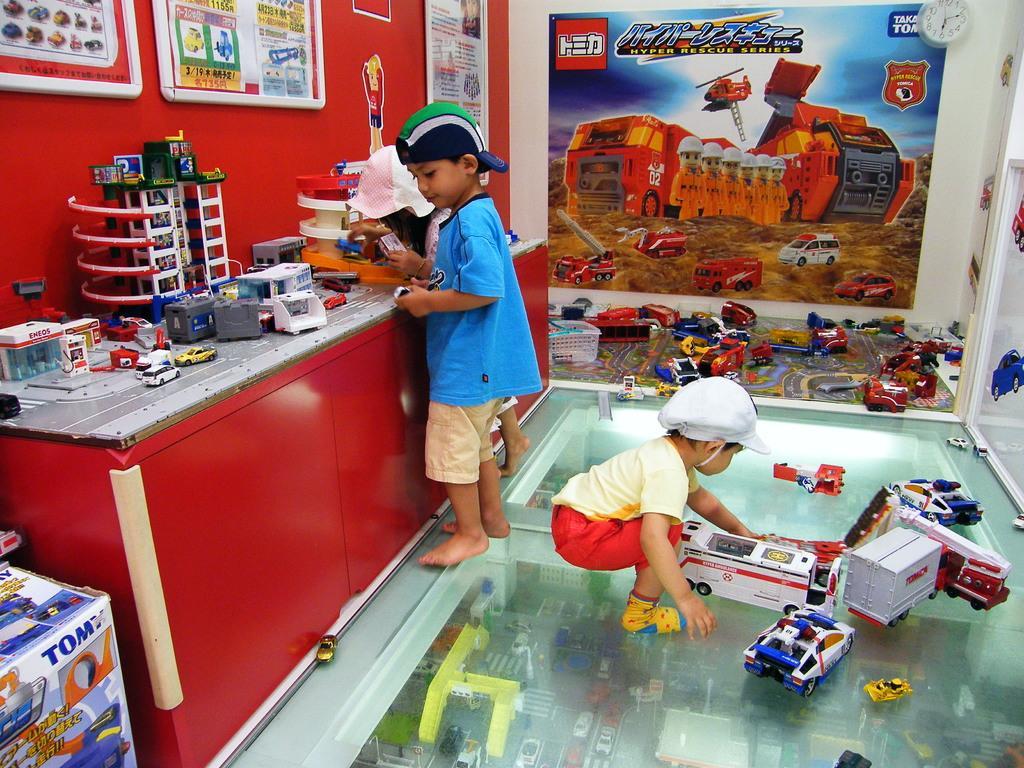Describe this image in one or two sentences. This picture is an inside view of a room. In the center of the image we can see a kid is bending and wearing a dress, cap and holding a toy. On the left side of the image we can see two kids are standing and holding the toys. In-front of them, we can see the cupboards, toys. In the background of the image we can see the toys, box, posters on the wall, boards on the wall, clock, door. At the bottom of the image we can see the floor. 